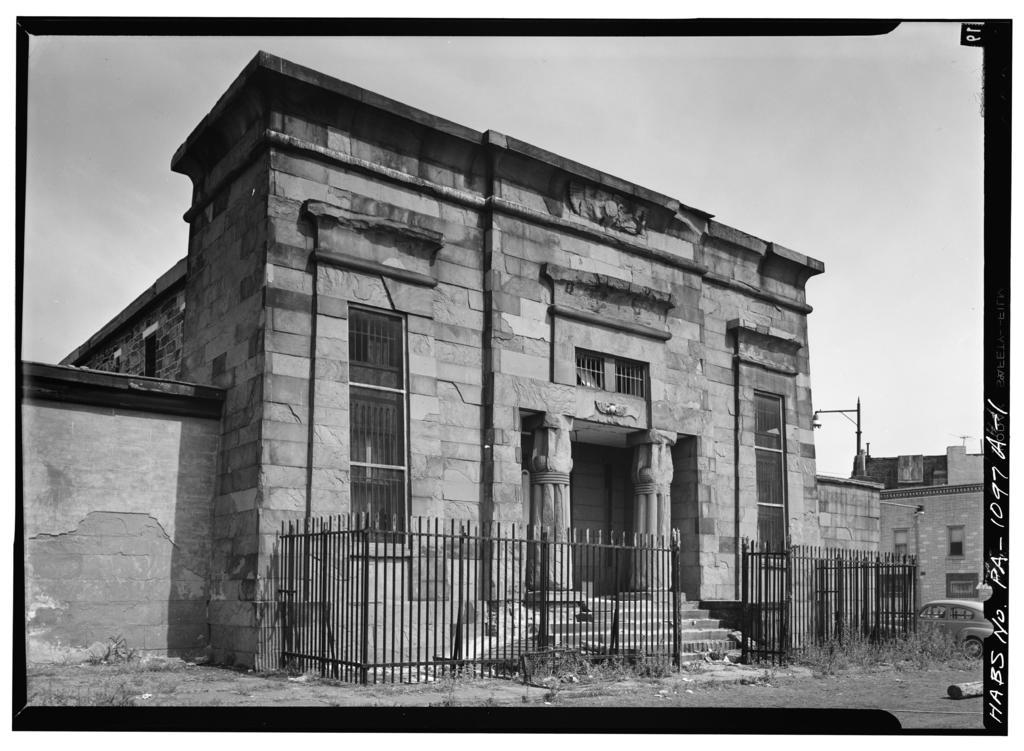What is the color scheme of the image? The image is black and white. What is the main subject in the center of the image? There is a building and fencing in the center of the image. What can be seen in the background of the image? There are clouds and the sky visible in the background of the image. Where is the sack of grain located in the image? There is no sack of grain present in the image. Can you see any rabbits in the image? There are no rabbits present in the image. 